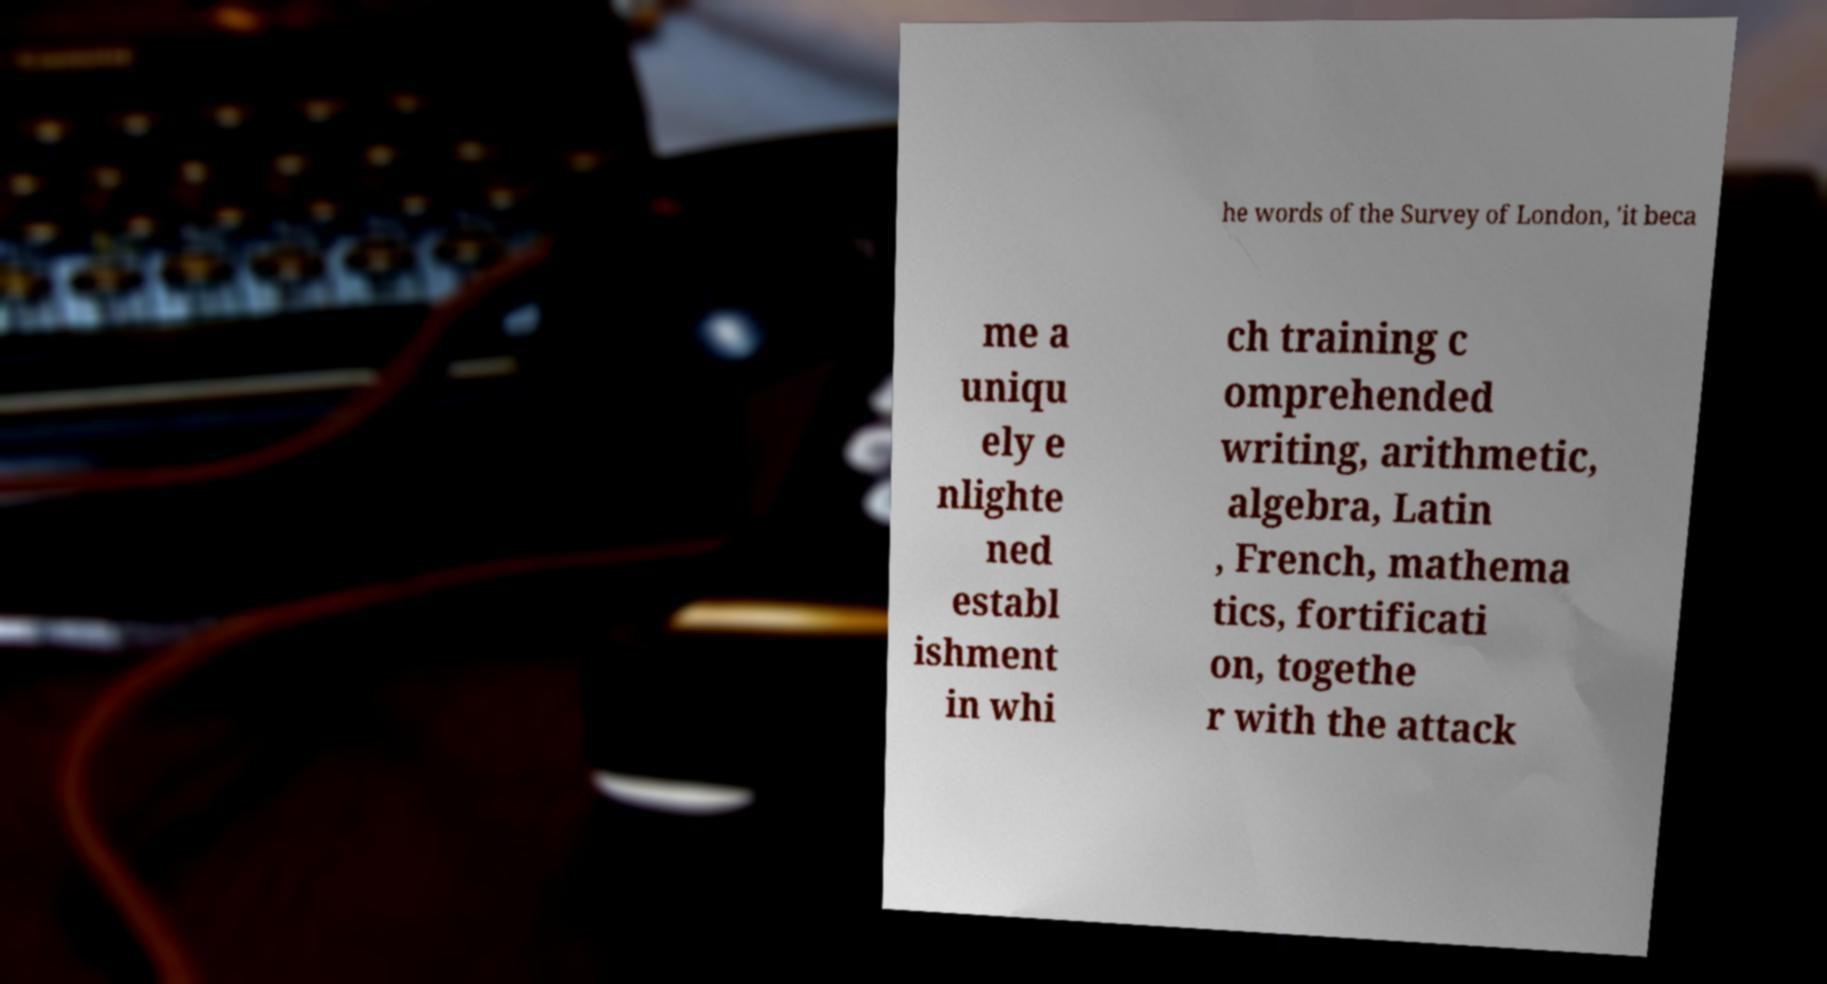Please read and relay the text visible in this image. What does it say? he words of the Survey of London, 'it beca me a uniqu ely e nlighte ned establ ishment in whi ch training c omprehended writing, arithmetic, algebra, Latin , French, mathema tics, fortificati on, togethe r with the attack 